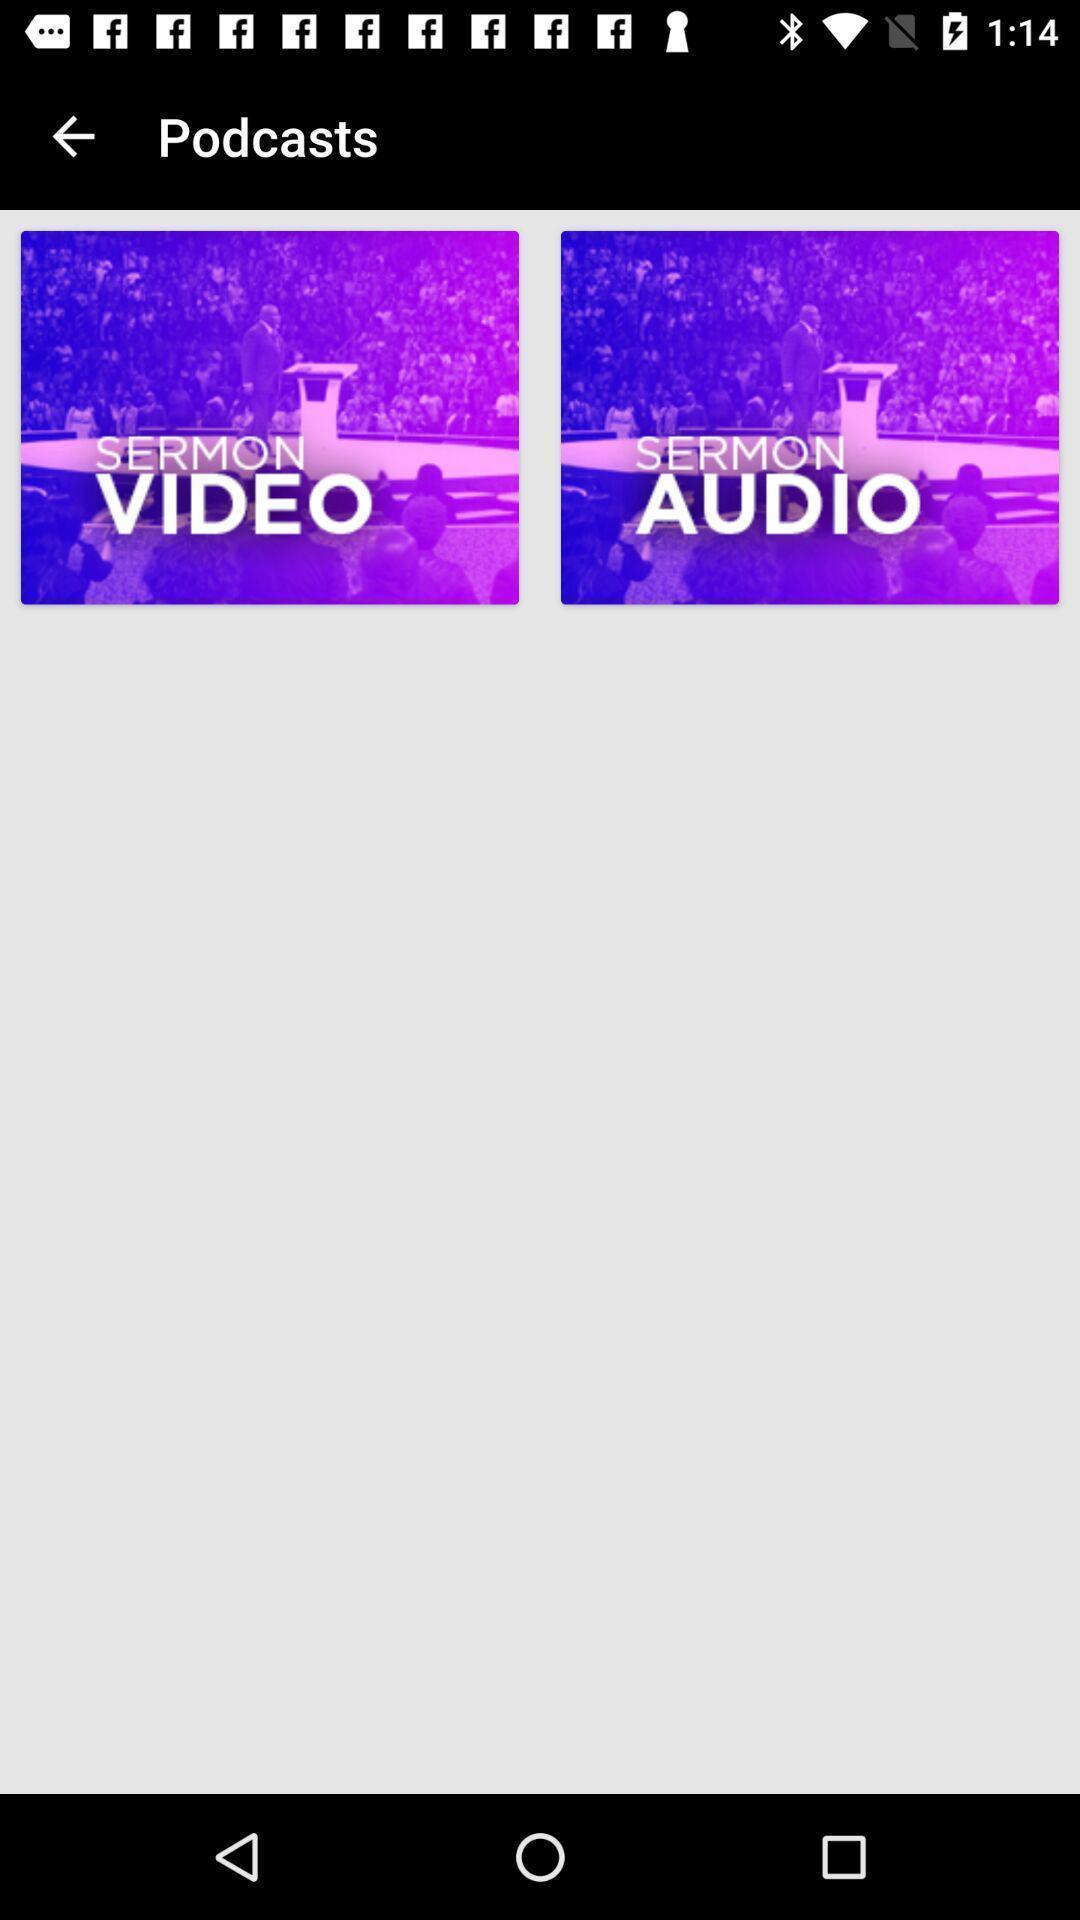Give me a narrative description of this picture. Screen shows audio and video options in podcast app. 